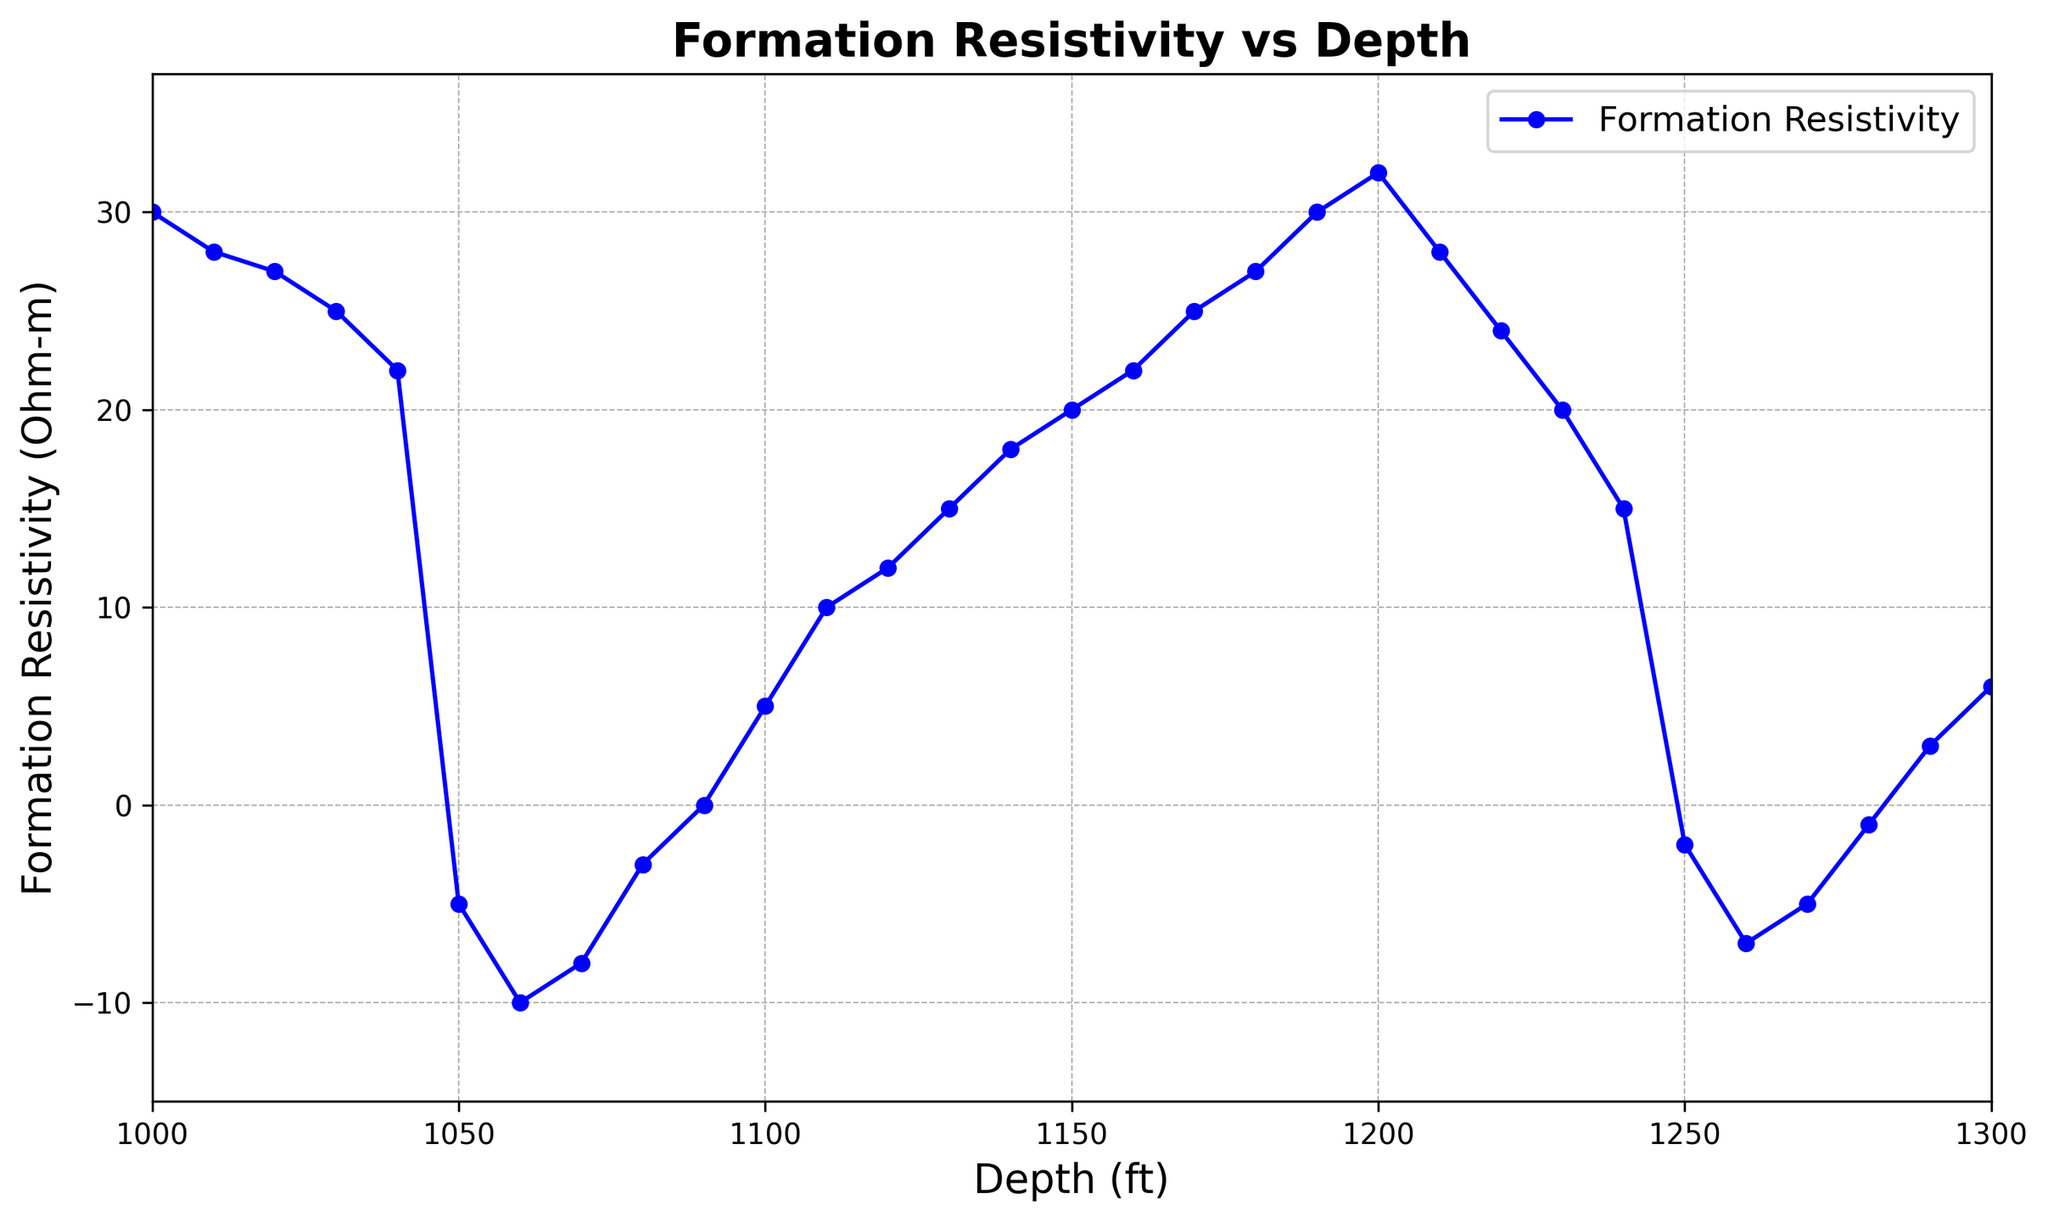What is the depth interval showing the highest resistivity value? The line chart shows a peak in the resistivity curve. By finding the highest point on the plot, we can identify the corresponding depth interval.
Answer: 1000-1005 ft At what depth does the resistivity first drop into negative values? By scanning the resistivity values from the top of the chart downward, the first instance of a negative value occurs at a specific depth.
Answer: 1050 ft Calculate the average resistivity between depths 1040 ft and 1090 ft. Identify all the resistivity values between 1040 ft and 1090 ft, then sum these values and divide by the number of values. Resistivities: (22, -5, -10, -8, -3, 0). Sum = 22 - 5 - 10 - 8 - 3 + 0 = -4. There are 6 values, average = -4/6 ≈ -0.67
Answer: -0.67 Ohm-m Compare the resistivity at 1100 ft and 1250 ft. Which one is higher and by how much? Find the resistivity at both depths: 1100 ft (5 Ohm-m) and 1250 ft (-2 Ohm-m). Subtract the resistivity at 1250 ft from the value at 1100 ft. Difference = 5 - (-2) = 5 + 2 = 7 Ohm-m.
Answer: 1100 ft by 7 Ohm-m What is the range of depths where negative resistivity values occur? Look for the depth intervals in the chart where the resistivity curve dips below zero. These occur between specific depths noted in the data.
Answer: 1050 ft to 1280 ft Identify the depth where the resistivity starts rising back after reaching its lowest point. The lowest resistivity value is -10 Ohm-m at 1060 ft. Look immediately after this depth to see where the resistivity starts increasing again.
Answer: 1070 ft Determine the median resistivity value between 1000 ft and 1300 ft. List all the resistivity values between these depths, sort them, and find the middle value (or the average of the two middle values if the count is even). Sorted values: -10, -8, -7, -5, -5, -3, -2, -1, 0, 3, 5, 6, 10, 12, 15, 18, 20, 22, 24, 25, 27, 27, 28, 28, 30, 30, 32. Median = 15th and 16th values = average of 15 and 18 = 16.5
Answer: 16.5 Ohm-m How does the resistivity trend change after 1090 ft? Observe the chart for the trend in resistivity values immediately following 1090 ft. Note whether the values are increasing, decreasing, or showing a cyclic pattern.
Answer: Increasing trend 